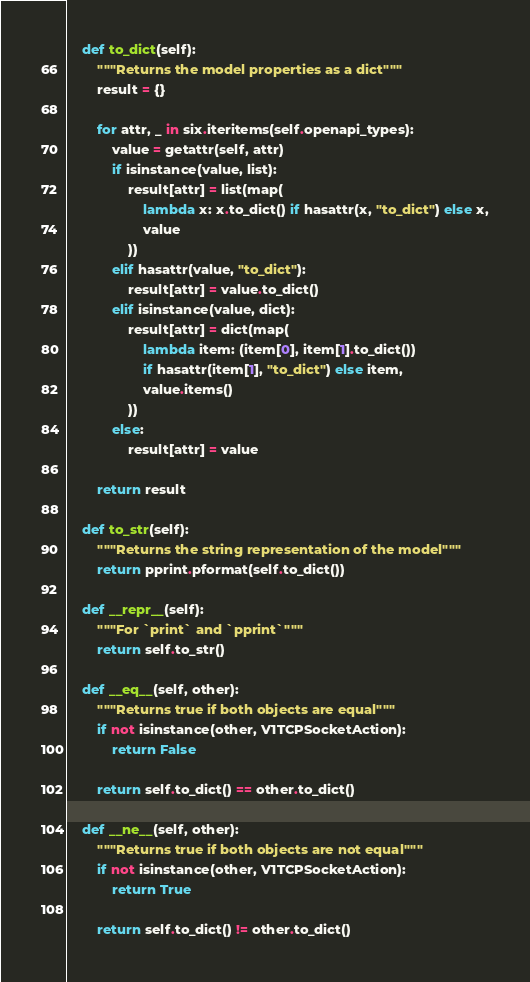Convert code to text. <code><loc_0><loc_0><loc_500><loc_500><_Python_>
    def to_dict(self):
        """Returns the model properties as a dict"""
        result = {}

        for attr, _ in six.iteritems(self.openapi_types):
            value = getattr(self, attr)
            if isinstance(value, list):
                result[attr] = list(map(
                    lambda x: x.to_dict() if hasattr(x, "to_dict") else x,
                    value
                ))
            elif hasattr(value, "to_dict"):
                result[attr] = value.to_dict()
            elif isinstance(value, dict):
                result[attr] = dict(map(
                    lambda item: (item[0], item[1].to_dict())
                    if hasattr(item[1], "to_dict") else item,
                    value.items()
                ))
            else:
                result[attr] = value

        return result

    def to_str(self):
        """Returns the string representation of the model"""
        return pprint.pformat(self.to_dict())

    def __repr__(self):
        """For `print` and `pprint`"""
        return self.to_str()

    def __eq__(self, other):
        """Returns true if both objects are equal"""
        if not isinstance(other, V1TCPSocketAction):
            return False

        return self.to_dict() == other.to_dict()

    def __ne__(self, other):
        """Returns true if both objects are not equal"""
        if not isinstance(other, V1TCPSocketAction):
            return True

        return self.to_dict() != other.to_dict()
</code> 